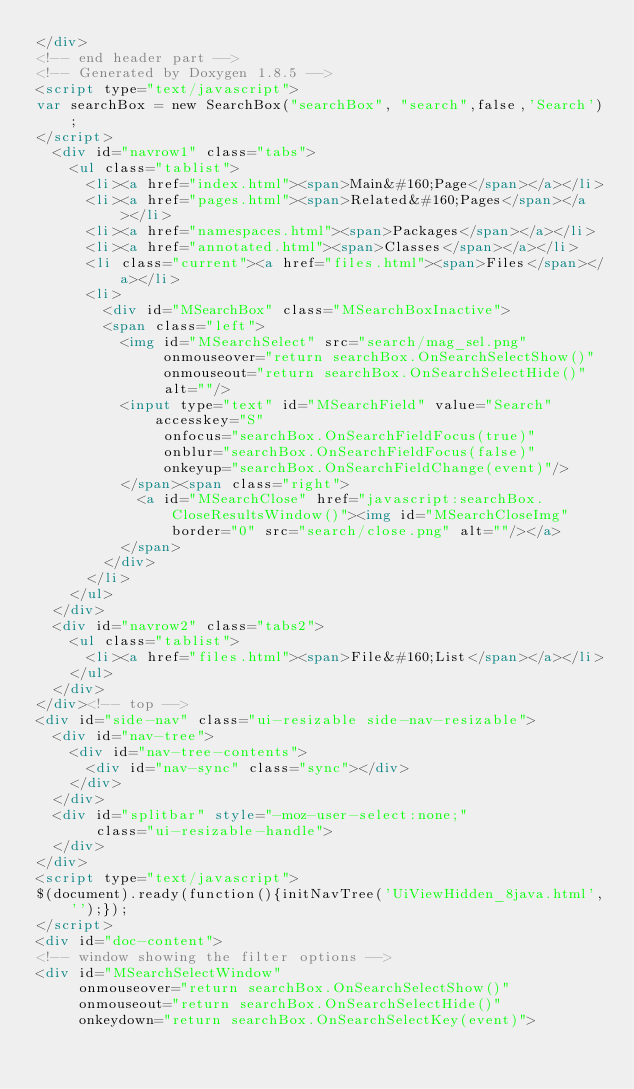Convert code to text. <code><loc_0><loc_0><loc_500><loc_500><_HTML_></div>
<!-- end header part -->
<!-- Generated by Doxygen 1.8.5 -->
<script type="text/javascript">
var searchBox = new SearchBox("searchBox", "search",false,'Search');
</script>
  <div id="navrow1" class="tabs">
    <ul class="tablist">
      <li><a href="index.html"><span>Main&#160;Page</span></a></li>
      <li><a href="pages.html"><span>Related&#160;Pages</span></a></li>
      <li><a href="namespaces.html"><span>Packages</span></a></li>
      <li><a href="annotated.html"><span>Classes</span></a></li>
      <li class="current"><a href="files.html"><span>Files</span></a></li>
      <li>
        <div id="MSearchBox" class="MSearchBoxInactive">
        <span class="left">
          <img id="MSearchSelect" src="search/mag_sel.png"
               onmouseover="return searchBox.OnSearchSelectShow()"
               onmouseout="return searchBox.OnSearchSelectHide()"
               alt=""/>
          <input type="text" id="MSearchField" value="Search" accesskey="S"
               onfocus="searchBox.OnSearchFieldFocus(true)" 
               onblur="searchBox.OnSearchFieldFocus(false)" 
               onkeyup="searchBox.OnSearchFieldChange(event)"/>
          </span><span class="right">
            <a id="MSearchClose" href="javascript:searchBox.CloseResultsWindow()"><img id="MSearchCloseImg" border="0" src="search/close.png" alt=""/></a>
          </span>
        </div>
      </li>
    </ul>
  </div>
  <div id="navrow2" class="tabs2">
    <ul class="tablist">
      <li><a href="files.html"><span>File&#160;List</span></a></li>
    </ul>
  </div>
</div><!-- top -->
<div id="side-nav" class="ui-resizable side-nav-resizable">
  <div id="nav-tree">
    <div id="nav-tree-contents">
      <div id="nav-sync" class="sync"></div>
    </div>
  </div>
  <div id="splitbar" style="-moz-user-select:none;" 
       class="ui-resizable-handle">
  </div>
</div>
<script type="text/javascript">
$(document).ready(function(){initNavTree('UiViewHidden_8java.html','');});
</script>
<div id="doc-content">
<!-- window showing the filter options -->
<div id="MSearchSelectWindow"
     onmouseover="return searchBox.OnSearchSelectShow()"
     onmouseout="return searchBox.OnSearchSelectHide()"
     onkeydown="return searchBox.OnSearchSelectKey(event)"></code> 